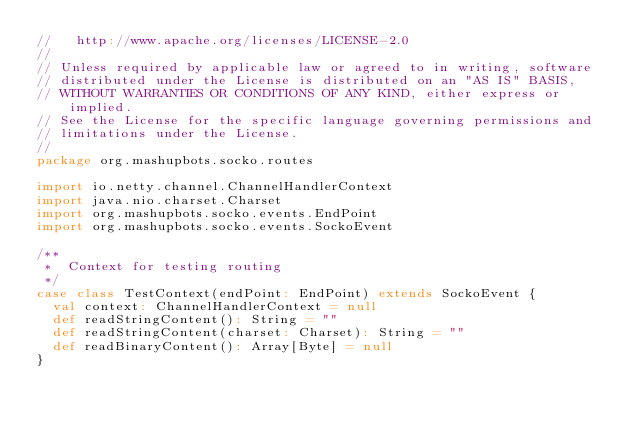<code> <loc_0><loc_0><loc_500><loc_500><_Scala_>//   http://www.apache.org/licenses/LICENSE-2.0
//
// Unless required by applicable law or agreed to in writing, software
// distributed under the License is distributed on an "AS IS" BASIS,
// WITHOUT WARRANTIES OR CONDITIONS OF ANY KIND, either express or implied.
// See the License for the specific language governing permissions and
// limitations under the License.
//
package org.mashupbots.socko.routes

import io.netty.channel.ChannelHandlerContext
import java.nio.charset.Charset
import org.mashupbots.socko.events.EndPoint
import org.mashupbots.socko.events.SockoEvent

/**
 *  Context for testing routing
 */
case class TestContext(endPoint: EndPoint) extends SockoEvent {
  val context: ChannelHandlerContext = null
  def readStringContent(): String = ""
  def readStringContent(charset: Charset): String = ""
  def readBinaryContent(): Array[Byte] = null
}
</code> 